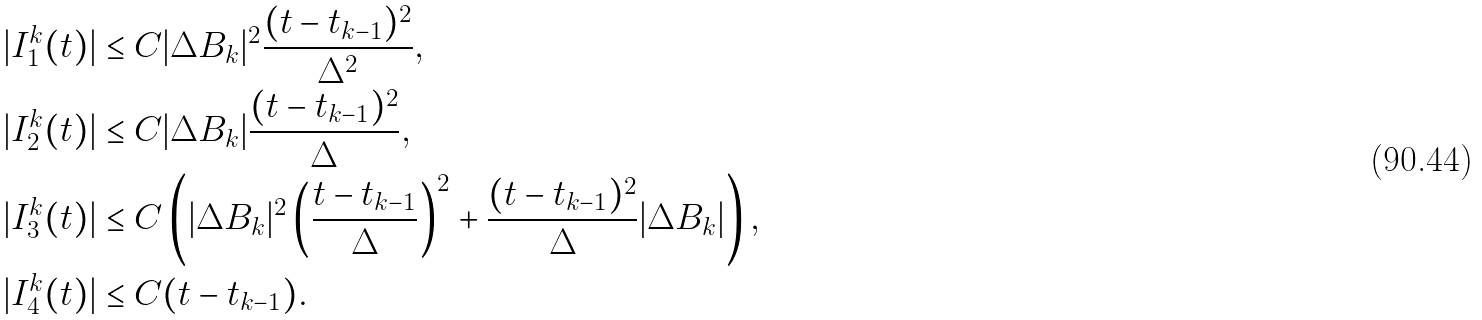<formula> <loc_0><loc_0><loc_500><loc_500>| I _ { 1 } ^ { k } ( t ) | & \leq C | \Delta B _ { k } | ^ { 2 } \frac { ( t - t _ { k - 1 } ) ^ { 2 } } { \Delta ^ { 2 } } , \\ | I _ { 2 } ^ { k } ( t ) | & \leq C | \Delta B _ { k } | \frac { ( t - t _ { k - 1 } ) ^ { 2 } } { \Delta } , \\ | I _ { 3 } ^ { k } ( t ) | & \leq C \left ( | \Delta B _ { k } | ^ { 2 } \left ( \frac { t - t _ { k - 1 } } { \Delta } \right ) ^ { 2 } + \frac { ( t - t _ { k - 1 } ) ^ { 2 } } { \Delta } | \Delta B _ { k } | \right ) , \\ | I _ { 4 } ^ { k } ( t ) | & \leq C ( t - t _ { k - 1 } ) .</formula> 